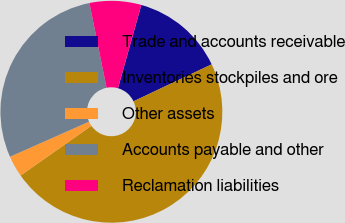Convert chart. <chart><loc_0><loc_0><loc_500><loc_500><pie_chart><fcel>Trade and accounts receivable<fcel>Inventories stockpiles and ore<fcel>Other assets<fcel>Accounts payable and other<fcel>Reclamation liabilities<nl><fcel>13.62%<fcel>47.29%<fcel>3.1%<fcel>28.48%<fcel>7.52%<nl></chart> 